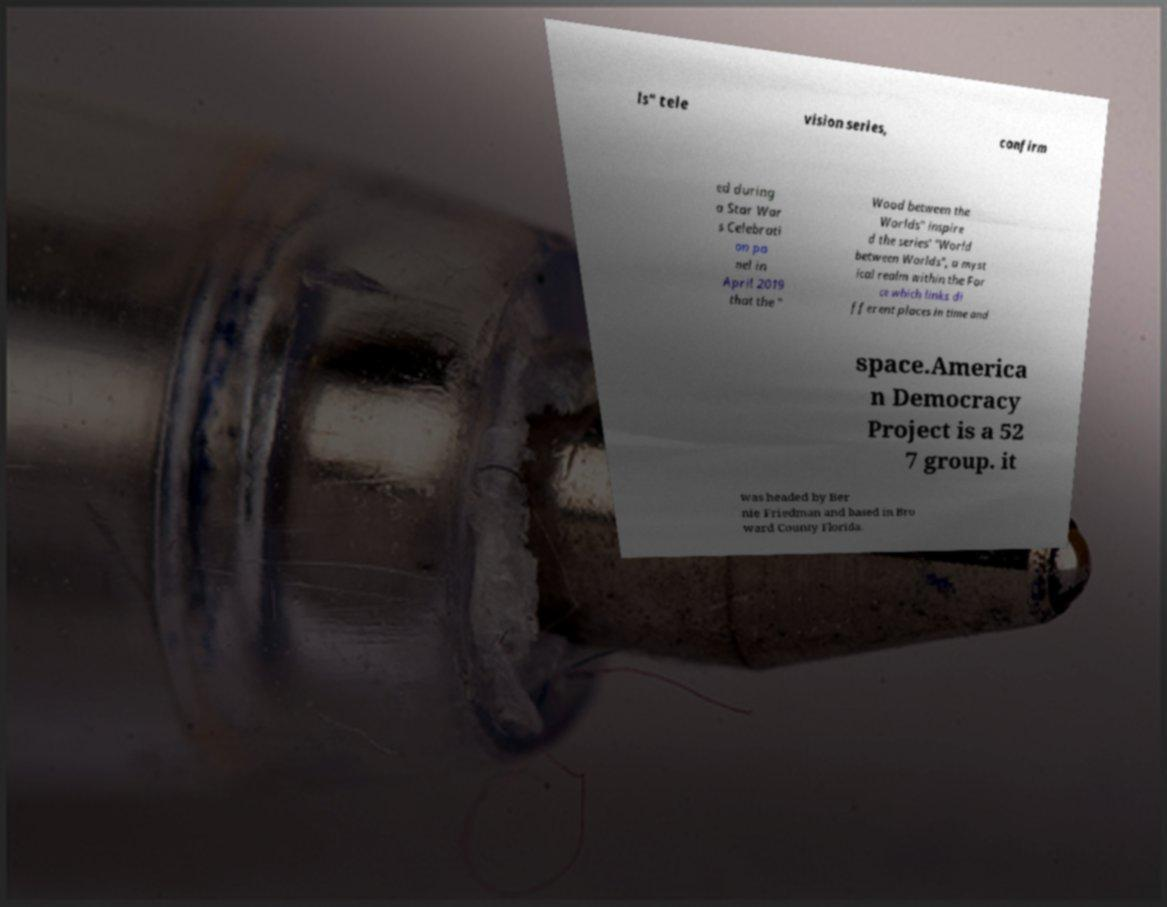For documentation purposes, I need the text within this image transcribed. Could you provide that? ls" tele vision series, confirm ed during a Star War s Celebrati on pa nel in April 2019 that the " Wood between the Worlds" inspire d the series' "World between Worlds", a myst ical realm within the For ce which links di fferent places in time and space.America n Democracy Project is a 52 7 group. it was headed by Ber nie Friedman and based in Bro ward County Florida. 